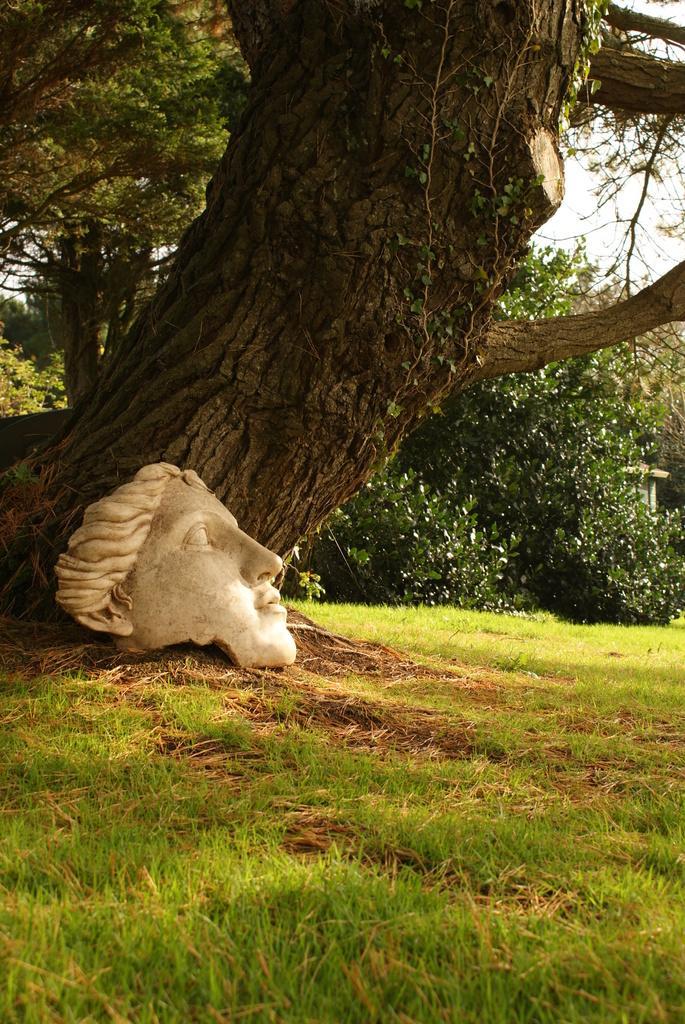Describe this image in one or two sentences. In this image in the center there is a tree and there is a sculpture, at the bottom there is grass. And in the background there are some trees and sky. 